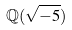<formula> <loc_0><loc_0><loc_500><loc_500>\mathbb { Q } ( \sqrt { - 5 } )</formula> 